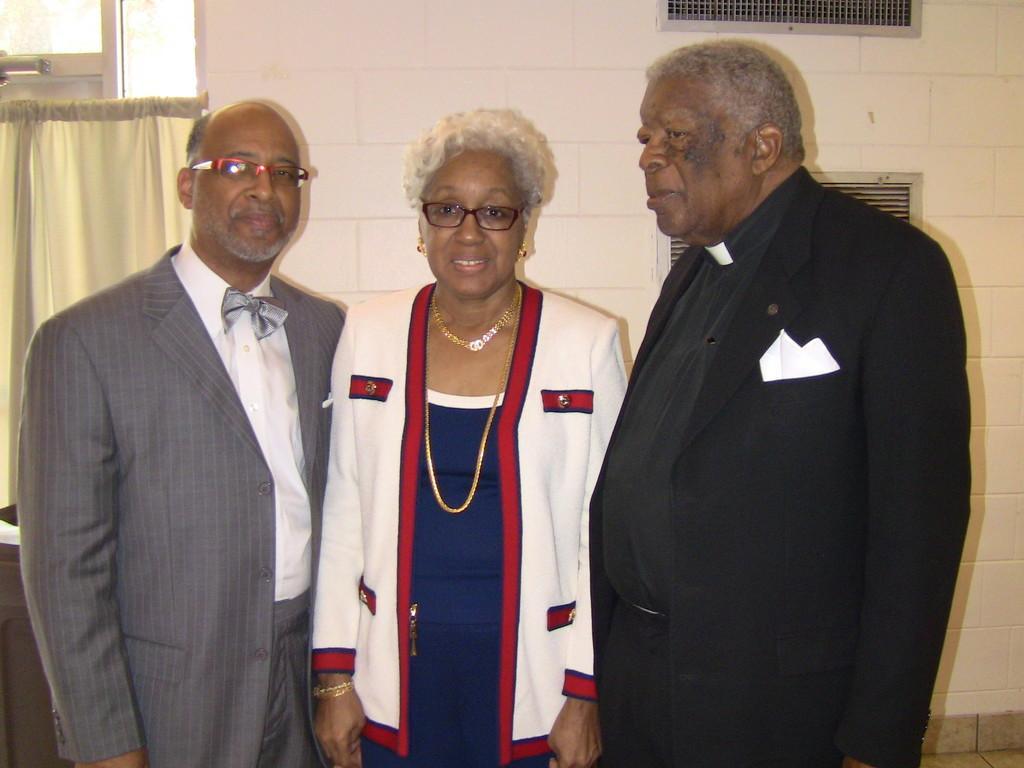Describe this image in one or two sentences. In this image I can see two men wearing blazers and a woman wearing white, red and blue colored dress are standing. In the background I can see the window, the curtain, the white colored wall and two vents to the wall. 